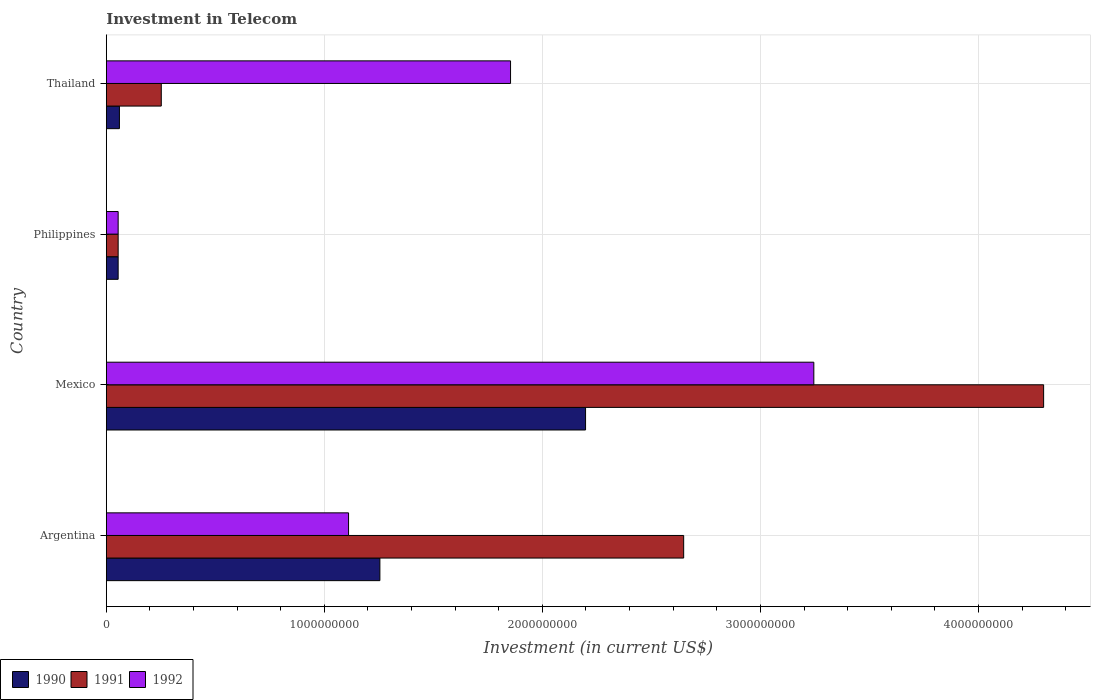How many groups of bars are there?
Your answer should be very brief. 4. Are the number of bars per tick equal to the number of legend labels?
Your response must be concise. Yes. How many bars are there on the 2nd tick from the top?
Provide a short and direct response. 3. How many bars are there on the 1st tick from the bottom?
Your answer should be compact. 3. What is the amount invested in telecom in 1990 in Thailand?
Your answer should be very brief. 6.00e+07. Across all countries, what is the maximum amount invested in telecom in 1991?
Offer a terse response. 4.30e+09. Across all countries, what is the minimum amount invested in telecom in 1991?
Your answer should be very brief. 5.42e+07. In which country was the amount invested in telecom in 1990 maximum?
Your response must be concise. Mexico. In which country was the amount invested in telecom in 1990 minimum?
Offer a very short reply. Philippines. What is the total amount invested in telecom in 1990 in the graph?
Keep it short and to the point. 3.57e+09. What is the difference between the amount invested in telecom in 1991 in Philippines and that in Thailand?
Your response must be concise. -1.98e+08. What is the difference between the amount invested in telecom in 1990 in Argentina and the amount invested in telecom in 1991 in Philippines?
Make the answer very short. 1.20e+09. What is the average amount invested in telecom in 1991 per country?
Give a very brief answer. 1.81e+09. What is the difference between the amount invested in telecom in 1990 and amount invested in telecom in 1992 in Philippines?
Give a very brief answer. 0. In how many countries, is the amount invested in telecom in 1992 greater than 4200000000 US$?
Keep it short and to the point. 0. What is the ratio of the amount invested in telecom in 1991 in Argentina to that in Philippines?
Your response must be concise. 48.86. Is the difference between the amount invested in telecom in 1990 in Mexico and Thailand greater than the difference between the amount invested in telecom in 1992 in Mexico and Thailand?
Provide a succinct answer. Yes. What is the difference between the highest and the second highest amount invested in telecom in 1990?
Offer a terse response. 9.43e+08. What is the difference between the highest and the lowest amount invested in telecom in 1990?
Keep it short and to the point. 2.14e+09. What does the 3rd bar from the top in Philippines represents?
Offer a very short reply. 1990. What does the 1st bar from the bottom in Philippines represents?
Provide a short and direct response. 1990. How many bars are there?
Provide a short and direct response. 12. Are all the bars in the graph horizontal?
Keep it short and to the point. Yes. How many countries are there in the graph?
Ensure brevity in your answer.  4. What is the difference between two consecutive major ticks on the X-axis?
Your response must be concise. 1.00e+09. Are the values on the major ticks of X-axis written in scientific E-notation?
Offer a terse response. No. Does the graph contain grids?
Provide a succinct answer. Yes. What is the title of the graph?
Make the answer very short. Investment in Telecom. What is the label or title of the X-axis?
Offer a terse response. Investment (in current US$). What is the Investment (in current US$) of 1990 in Argentina?
Provide a short and direct response. 1.25e+09. What is the Investment (in current US$) in 1991 in Argentina?
Your answer should be compact. 2.65e+09. What is the Investment (in current US$) in 1992 in Argentina?
Offer a very short reply. 1.11e+09. What is the Investment (in current US$) in 1990 in Mexico?
Your response must be concise. 2.20e+09. What is the Investment (in current US$) in 1991 in Mexico?
Offer a very short reply. 4.30e+09. What is the Investment (in current US$) in 1992 in Mexico?
Your answer should be very brief. 3.24e+09. What is the Investment (in current US$) of 1990 in Philippines?
Provide a short and direct response. 5.42e+07. What is the Investment (in current US$) of 1991 in Philippines?
Give a very brief answer. 5.42e+07. What is the Investment (in current US$) of 1992 in Philippines?
Your response must be concise. 5.42e+07. What is the Investment (in current US$) in 1990 in Thailand?
Your answer should be compact. 6.00e+07. What is the Investment (in current US$) in 1991 in Thailand?
Your answer should be compact. 2.52e+08. What is the Investment (in current US$) of 1992 in Thailand?
Provide a succinct answer. 1.85e+09. Across all countries, what is the maximum Investment (in current US$) of 1990?
Offer a very short reply. 2.20e+09. Across all countries, what is the maximum Investment (in current US$) of 1991?
Your response must be concise. 4.30e+09. Across all countries, what is the maximum Investment (in current US$) of 1992?
Give a very brief answer. 3.24e+09. Across all countries, what is the minimum Investment (in current US$) in 1990?
Provide a short and direct response. 5.42e+07. Across all countries, what is the minimum Investment (in current US$) in 1991?
Give a very brief answer. 5.42e+07. Across all countries, what is the minimum Investment (in current US$) of 1992?
Give a very brief answer. 5.42e+07. What is the total Investment (in current US$) in 1990 in the graph?
Offer a terse response. 3.57e+09. What is the total Investment (in current US$) of 1991 in the graph?
Your answer should be compact. 7.25e+09. What is the total Investment (in current US$) in 1992 in the graph?
Your answer should be compact. 6.26e+09. What is the difference between the Investment (in current US$) of 1990 in Argentina and that in Mexico?
Make the answer very short. -9.43e+08. What is the difference between the Investment (in current US$) in 1991 in Argentina and that in Mexico?
Ensure brevity in your answer.  -1.65e+09. What is the difference between the Investment (in current US$) of 1992 in Argentina and that in Mexico?
Offer a very short reply. -2.13e+09. What is the difference between the Investment (in current US$) in 1990 in Argentina and that in Philippines?
Your answer should be compact. 1.20e+09. What is the difference between the Investment (in current US$) in 1991 in Argentina and that in Philippines?
Keep it short and to the point. 2.59e+09. What is the difference between the Investment (in current US$) of 1992 in Argentina and that in Philippines?
Ensure brevity in your answer.  1.06e+09. What is the difference between the Investment (in current US$) of 1990 in Argentina and that in Thailand?
Your answer should be very brief. 1.19e+09. What is the difference between the Investment (in current US$) of 1991 in Argentina and that in Thailand?
Offer a terse response. 2.40e+09. What is the difference between the Investment (in current US$) of 1992 in Argentina and that in Thailand?
Offer a very short reply. -7.43e+08. What is the difference between the Investment (in current US$) of 1990 in Mexico and that in Philippines?
Ensure brevity in your answer.  2.14e+09. What is the difference between the Investment (in current US$) of 1991 in Mexico and that in Philippines?
Provide a succinct answer. 4.24e+09. What is the difference between the Investment (in current US$) of 1992 in Mexico and that in Philippines?
Offer a terse response. 3.19e+09. What is the difference between the Investment (in current US$) of 1990 in Mexico and that in Thailand?
Provide a short and direct response. 2.14e+09. What is the difference between the Investment (in current US$) of 1991 in Mexico and that in Thailand?
Provide a succinct answer. 4.05e+09. What is the difference between the Investment (in current US$) of 1992 in Mexico and that in Thailand?
Provide a succinct answer. 1.39e+09. What is the difference between the Investment (in current US$) of 1990 in Philippines and that in Thailand?
Offer a terse response. -5.80e+06. What is the difference between the Investment (in current US$) in 1991 in Philippines and that in Thailand?
Your answer should be very brief. -1.98e+08. What is the difference between the Investment (in current US$) in 1992 in Philippines and that in Thailand?
Give a very brief answer. -1.80e+09. What is the difference between the Investment (in current US$) in 1990 in Argentina and the Investment (in current US$) in 1991 in Mexico?
Your response must be concise. -3.04e+09. What is the difference between the Investment (in current US$) of 1990 in Argentina and the Investment (in current US$) of 1992 in Mexico?
Make the answer very short. -1.99e+09. What is the difference between the Investment (in current US$) of 1991 in Argentina and the Investment (in current US$) of 1992 in Mexico?
Your answer should be compact. -5.97e+08. What is the difference between the Investment (in current US$) in 1990 in Argentina and the Investment (in current US$) in 1991 in Philippines?
Make the answer very short. 1.20e+09. What is the difference between the Investment (in current US$) in 1990 in Argentina and the Investment (in current US$) in 1992 in Philippines?
Make the answer very short. 1.20e+09. What is the difference between the Investment (in current US$) in 1991 in Argentina and the Investment (in current US$) in 1992 in Philippines?
Ensure brevity in your answer.  2.59e+09. What is the difference between the Investment (in current US$) in 1990 in Argentina and the Investment (in current US$) in 1991 in Thailand?
Offer a very short reply. 1.00e+09. What is the difference between the Investment (in current US$) of 1990 in Argentina and the Investment (in current US$) of 1992 in Thailand?
Give a very brief answer. -5.99e+08. What is the difference between the Investment (in current US$) of 1991 in Argentina and the Investment (in current US$) of 1992 in Thailand?
Your response must be concise. 7.94e+08. What is the difference between the Investment (in current US$) in 1990 in Mexico and the Investment (in current US$) in 1991 in Philippines?
Make the answer very short. 2.14e+09. What is the difference between the Investment (in current US$) of 1990 in Mexico and the Investment (in current US$) of 1992 in Philippines?
Provide a short and direct response. 2.14e+09. What is the difference between the Investment (in current US$) of 1991 in Mexico and the Investment (in current US$) of 1992 in Philippines?
Ensure brevity in your answer.  4.24e+09. What is the difference between the Investment (in current US$) of 1990 in Mexico and the Investment (in current US$) of 1991 in Thailand?
Keep it short and to the point. 1.95e+09. What is the difference between the Investment (in current US$) of 1990 in Mexico and the Investment (in current US$) of 1992 in Thailand?
Your answer should be compact. 3.44e+08. What is the difference between the Investment (in current US$) of 1991 in Mexico and the Investment (in current US$) of 1992 in Thailand?
Your answer should be very brief. 2.44e+09. What is the difference between the Investment (in current US$) of 1990 in Philippines and the Investment (in current US$) of 1991 in Thailand?
Make the answer very short. -1.98e+08. What is the difference between the Investment (in current US$) of 1990 in Philippines and the Investment (in current US$) of 1992 in Thailand?
Ensure brevity in your answer.  -1.80e+09. What is the difference between the Investment (in current US$) of 1991 in Philippines and the Investment (in current US$) of 1992 in Thailand?
Keep it short and to the point. -1.80e+09. What is the average Investment (in current US$) in 1990 per country?
Your answer should be compact. 8.92e+08. What is the average Investment (in current US$) of 1991 per country?
Make the answer very short. 1.81e+09. What is the average Investment (in current US$) in 1992 per country?
Your answer should be compact. 1.57e+09. What is the difference between the Investment (in current US$) of 1990 and Investment (in current US$) of 1991 in Argentina?
Make the answer very short. -1.39e+09. What is the difference between the Investment (in current US$) of 1990 and Investment (in current US$) of 1992 in Argentina?
Your response must be concise. 1.44e+08. What is the difference between the Investment (in current US$) of 1991 and Investment (in current US$) of 1992 in Argentina?
Keep it short and to the point. 1.54e+09. What is the difference between the Investment (in current US$) of 1990 and Investment (in current US$) of 1991 in Mexico?
Ensure brevity in your answer.  -2.10e+09. What is the difference between the Investment (in current US$) in 1990 and Investment (in current US$) in 1992 in Mexico?
Give a very brief answer. -1.05e+09. What is the difference between the Investment (in current US$) of 1991 and Investment (in current US$) of 1992 in Mexico?
Make the answer very short. 1.05e+09. What is the difference between the Investment (in current US$) of 1990 and Investment (in current US$) of 1991 in Thailand?
Your response must be concise. -1.92e+08. What is the difference between the Investment (in current US$) of 1990 and Investment (in current US$) of 1992 in Thailand?
Make the answer very short. -1.79e+09. What is the difference between the Investment (in current US$) in 1991 and Investment (in current US$) in 1992 in Thailand?
Keep it short and to the point. -1.60e+09. What is the ratio of the Investment (in current US$) of 1990 in Argentina to that in Mexico?
Your answer should be compact. 0.57. What is the ratio of the Investment (in current US$) in 1991 in Argentina to that in Mexico?
Give a very brief answer. 0.62. What is the ratio of the Investment (in current US$) of 1992 in Argentina to that in Mexico?
Offer a very short reply. 0.34. What is the ratio of the Investment (in current US$) of 1990 in Argentina to that in Philippines?
Give a very brief answer. 23.15. What is the ratio of the Investment (in current US$) in 1991 in Argentina to that in Philippines?
Offer a terse response. 48.86. What is the ratio of the Investment (in current US$) of 1992 in Argentina to that in Philippines?
Keep it short and to the point. 20.5. What is the ratio of the Investment (in current US$) in 1990 in Argentina to that in Thailand?
Provide a succinct answer. 20.91. What is the ratio of the Investment (in current US$) in 1991 in Argentina to that in Thailand?
Provide a succinct answer. 10.51. What is the ratio of the Investment (in current US$) of 1992 in Argentina to that in Thailand?
Provide a succinct answer. 0.6. What is the ratio of the Investment (in current US$) in 1990 in Mexico to that in Philippines?
Your answer should be very brief. 40.55. What is the ratio of the Investment (in current US$) of 1991 in Mexico to that in Philippines?
Your response must be concise. 79.32. What is the ratio of the Investment (in current US$) of 1992 in Mexico to that in Philippines?
Provide a short and direct response. 59.87. What is the ratio of the Investment (in current US$) in 1990 in Mexico to that in Thailand?
Your response must be concise. 36.63. What is the ratio of the Investment (in current US$) in 1991 in Mexico to that in Thailand?
Provide a short and direct response. 17.06. What is the ratio of the Investment (in current US$) of 1992 in Mexico to that in Thailand?
Your answer should be very brief. 1.75. What is the ratio of the Investment (in current US$) of 1990 in Philippines to that in Thailand?
Provide a succinct answer. 0.9. What is the ratio of the Investment (in current US$) in 1991 in Philippines to that in Thailand?
Offer a very short reply. 0.22. What is the ratio of the Investment (in current US$) of 1992 in Philippines to that in Thailand?
Make the answer very short. 0.03. What is the difference between the highest and the second highest Investment (in current US$) in 1990?
Ensure brevity in your answer.  9.43e+08. What is the difference between the highest and the second highest Investment (in current US$) of 1991?
Offer a very short reply. 1.65e+09. What is the difference between the highest and the second highest Investment (in current US$) in 1992?
Offer a terse response. 1.39e+09. What is the difference between the highest and the lowest Investment (in current US$) of 1990?
Offer a very short reply. 2.14e+09. What is the difference between the highest and the lowest Investment (in current US$) of 1991?
Give a very brief answer. 4.24e+09. What is the difference between the highest and the lowest Investment (in current US$) in 1992?
Provide a short and direct response. 3.19e+09. 